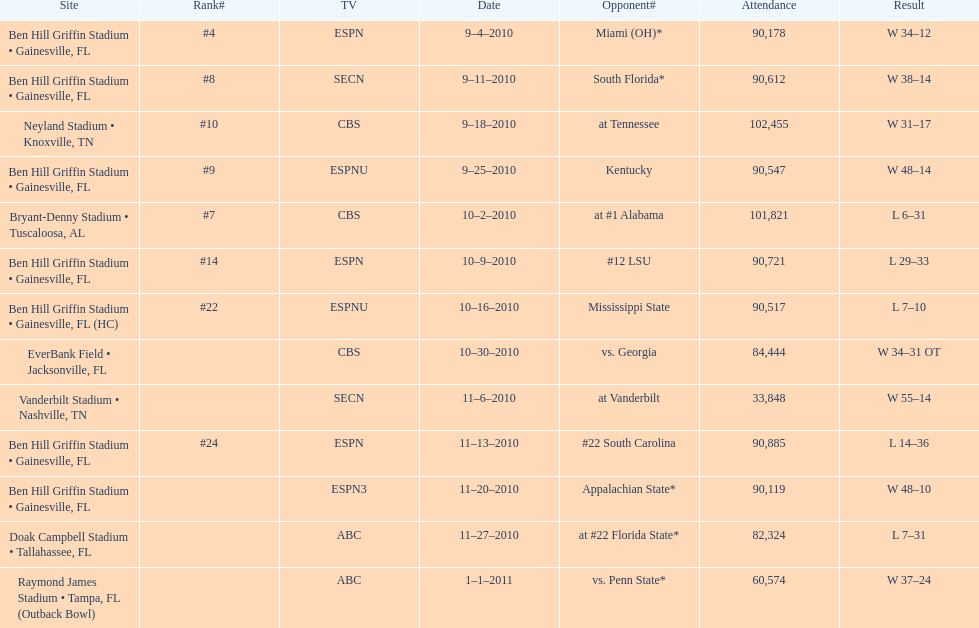How many consecutive weeks did the the gators win until the had their first lost in the 2010 season? 4. 